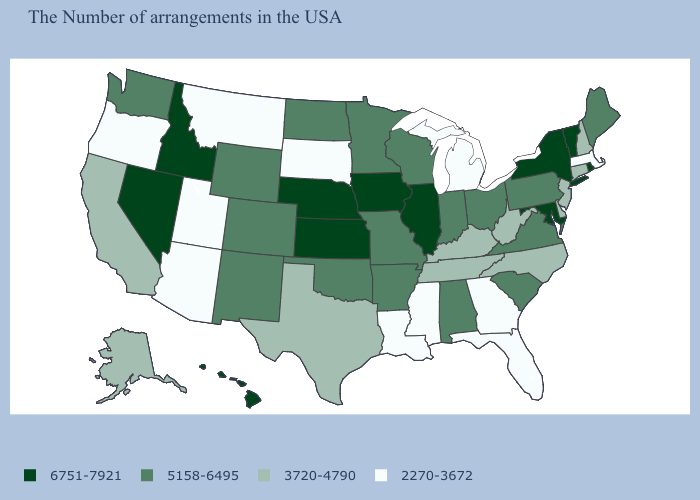Which states have the lowest value in the USA?
Quick response, please. Massachusetts, Florida, Georgia, Michigan, Mississippi, Louisiana, South Dakota, Utah, Montana, Arizona, Oregon. Does the first symbol in the legend represent the smallest category?
Write a very short answer. No. Does Massachusetts have the lowest value in the Northeast?
Answer briefly. Yes. How many symbols are there in the legend?
Short answer required. 4. Which states have the lowest value in the MidWest?
Write a very short answer. Michigan, South Dakota. Name the states that have a value in the range 3720-4790?
Concise answer only. New Hampshire, Connecticut, New Jersey, Delaware, North Carolina, West Virginia, Kentucky, Tennessee, Texas, California, Alaska. What is the highest value in the USA?
Be succinct. 6751-7921. What is the value of South Dakota?
Be succinct. 2270-3672. Does California have a higher value than Oregon?
Quick response, please. Yes. Is the legend a continuous bar?
Write a very short answer. No. Does Maryland have the highest value in the South?
Write a very short answer. Yes. What is the highest value in states that border Kentucky?
Write a very short answer. 6751-7921. Name the states that have a value in the range 2270-3672?
Answer briefly. Massachusetts, Florida, Georgia, Michigan, Mississippi, Louisiana, South Dakota, Utah, Montana, Arizona, Oregon. Among the states that border New Mexico , does Arizona have the lowest value?
Concise answer only. Yes. What is the value of Oregon?
Short answer required. 2270-3672. 